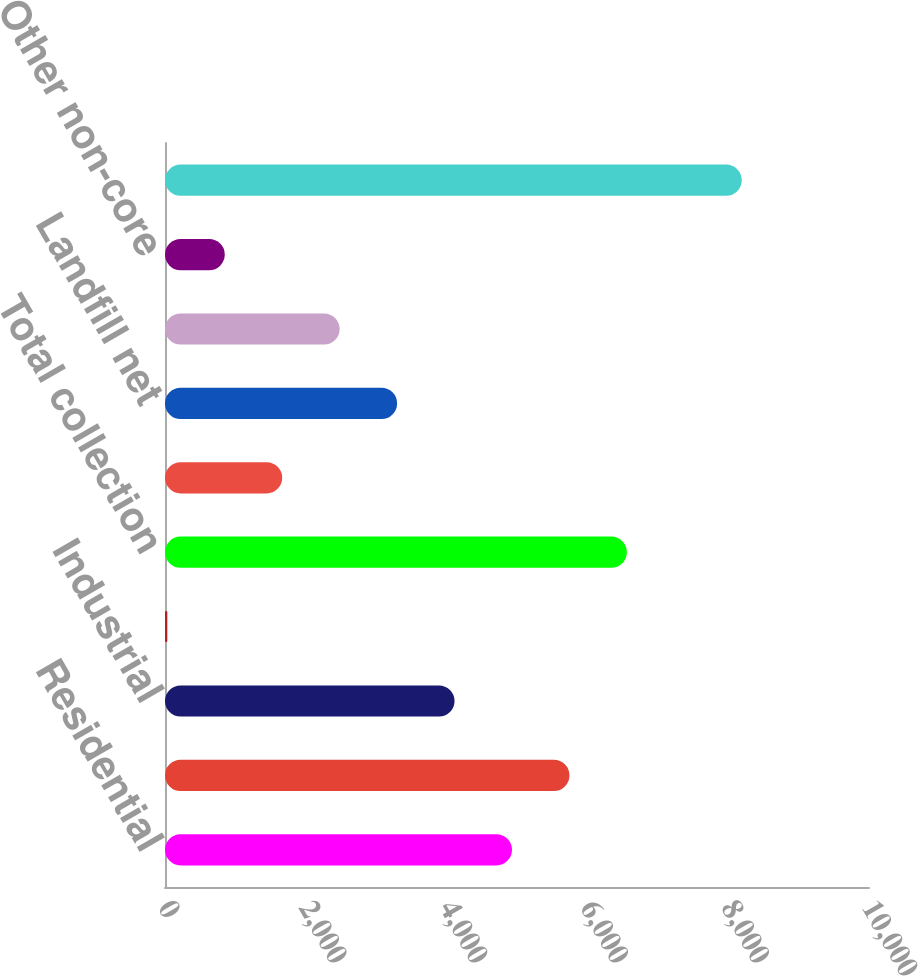<chart> <loc_0><loc_0><loc_500><loc_500><bar_chart><fcel>Residential<fcel>Commercial<fcel>Industrial<fcel>Other<fcel>Total collection<fcel>Transfer net<fcel>Landfill net<fcel>Sale of recyclable materials<fcel>Other non-core<fcel>Total revenue<nl><fcel>4928.9<fcel>5744.9<fcel>4112.9<fcel>32.9<fcel>6560.9<fcel>1664.9<fcel>3296.9<fcel>2480.9<fcel>848.9<fcel>8192.9<nl></chart> 